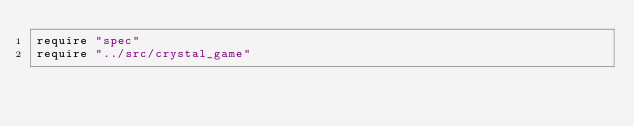Convert code to text. <code><loc_0><loc_0><loc_500><loc_500><_Crystal_>require "spec"
require "../src/crystal_game"
</code> 